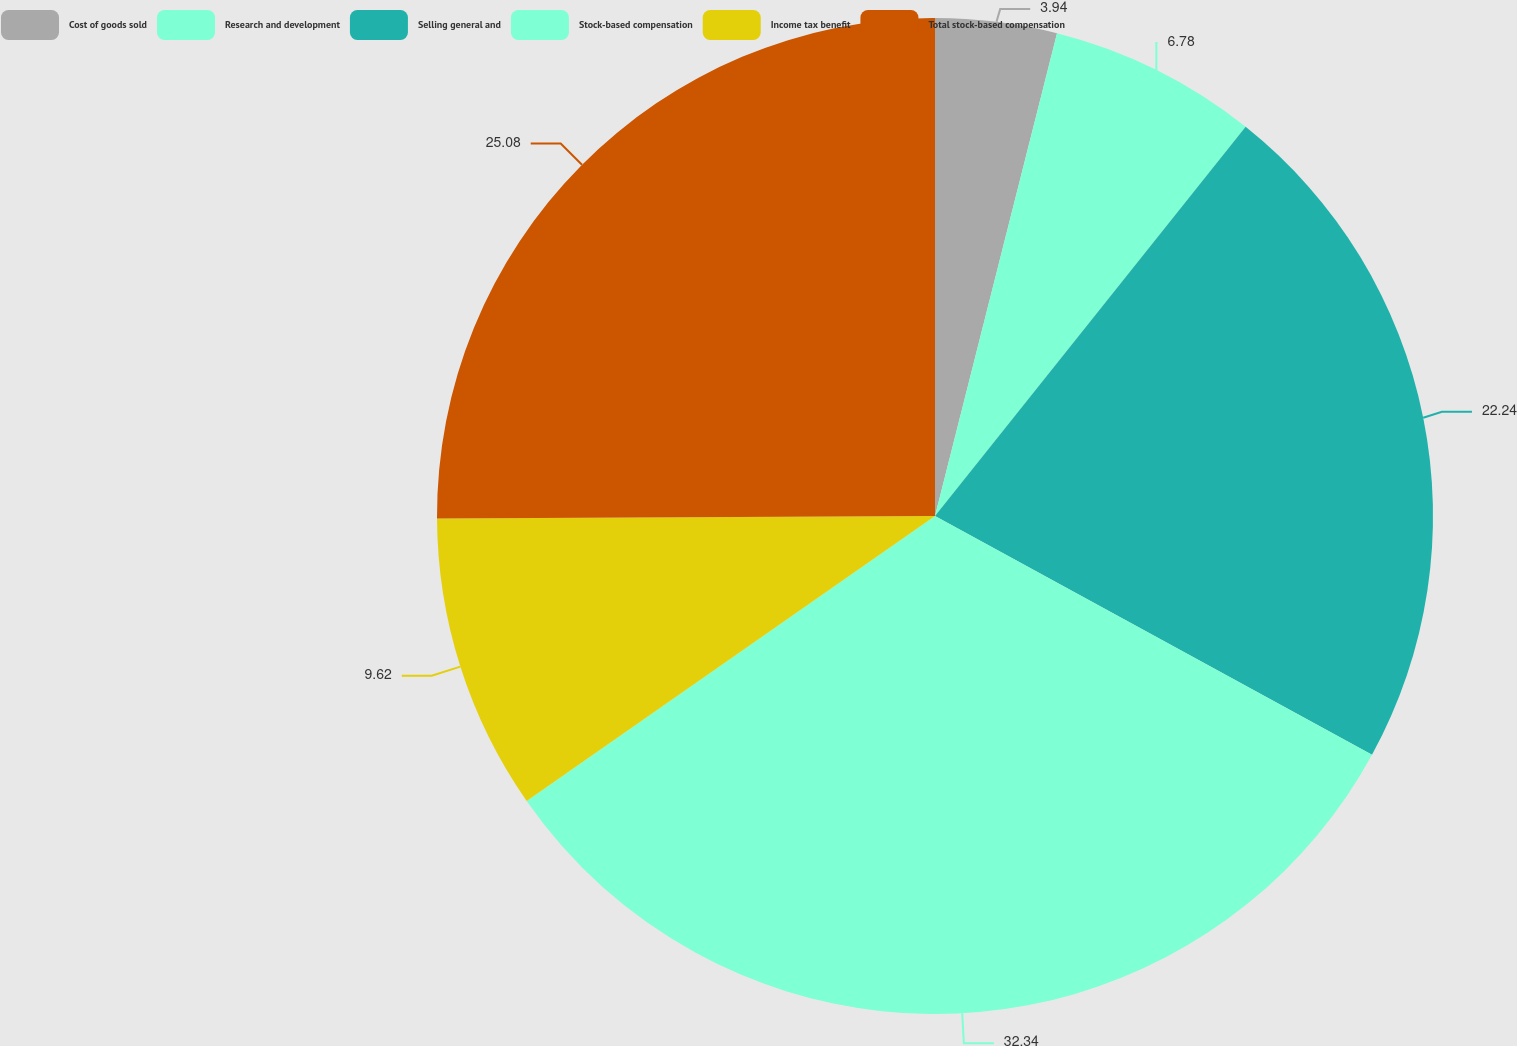Convert chart. <chart><loc_0><loc_0><loc_500><loc_500><pie_chart><fcel>Cost of goods sold<fcel>Research and development<fcel>Selling general and<fcel>Stock-based compensation<fcel>Income tax benefit<fcel>Total stock-based compensation<nl><fcel>3.94%<fcel>6.78%<fcel>22.24%<fcel>32.34%<fcel>9.62%<fcel>25.08%<nl></chart> 